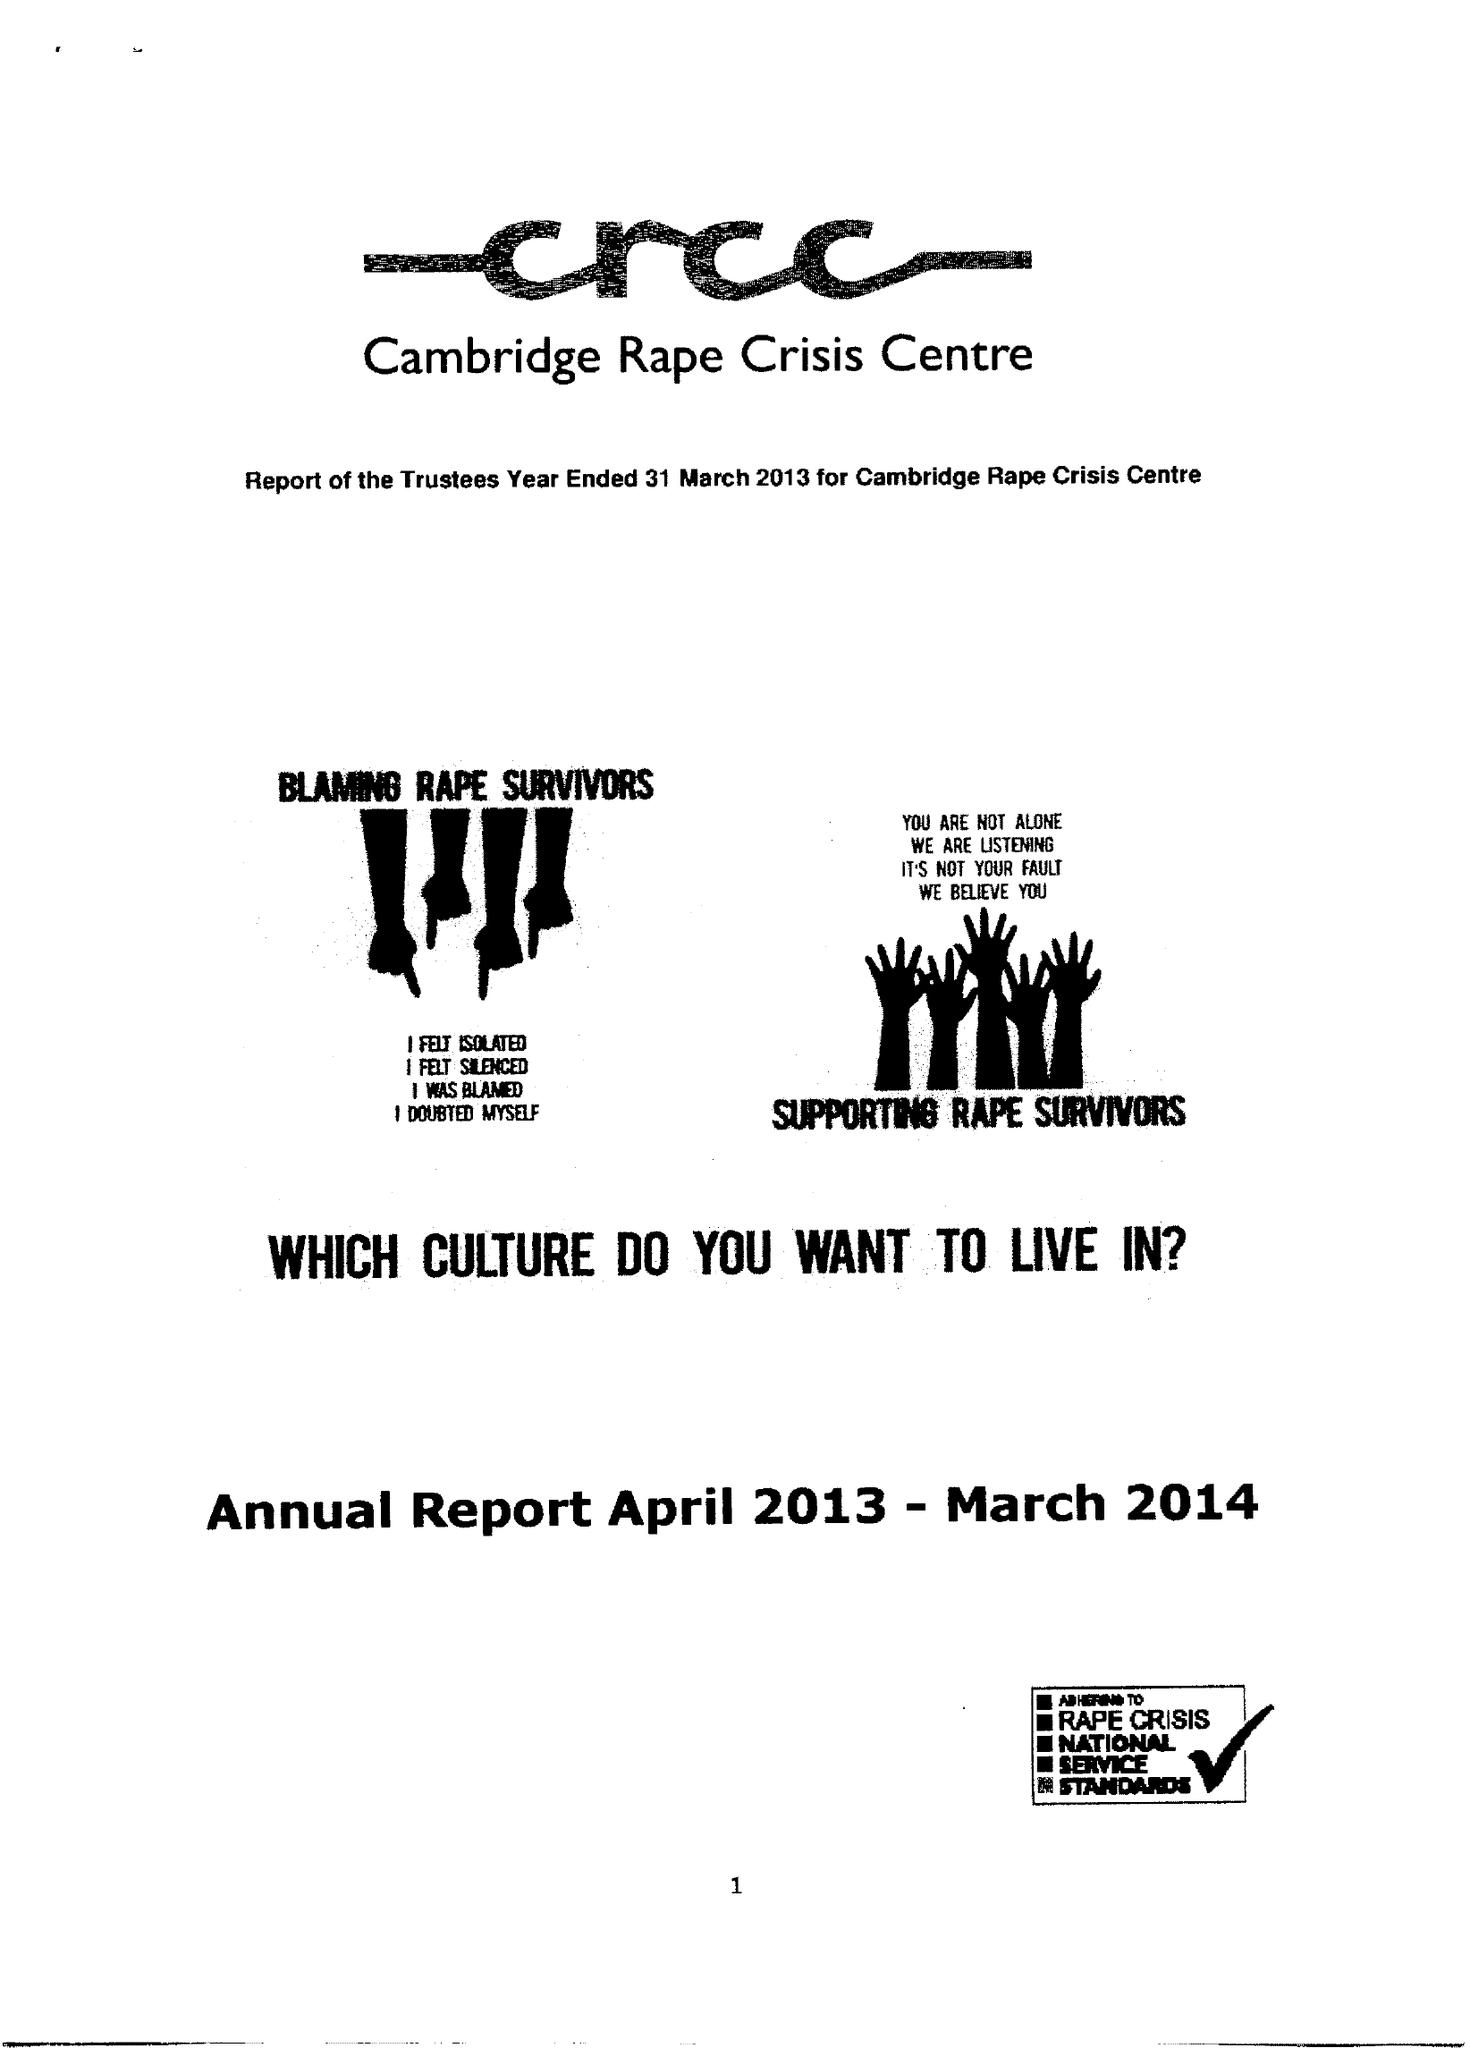What is the value for the charity_name?
Answer the question using a single word or phrase. Cambridge Rape Crisis Centre 